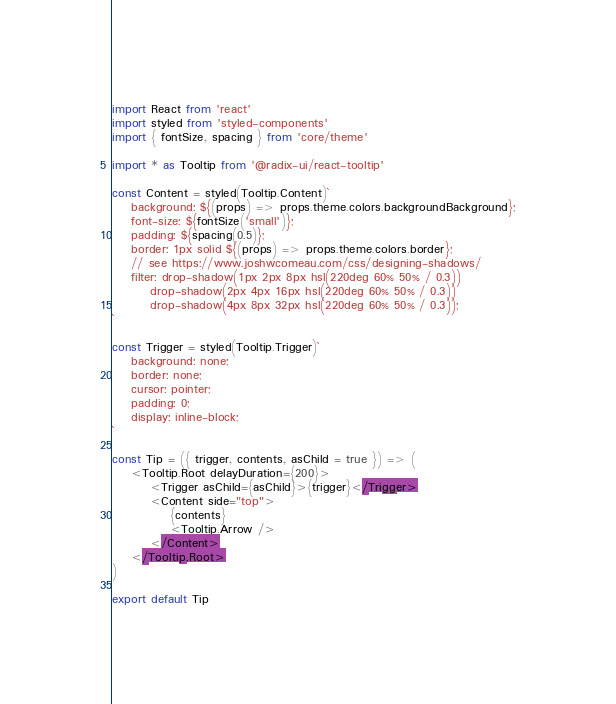Convert code to text. <code><loc_0><loc_0><loc_500><loc_500><_JavaScript_>import React from 'react'
import styled from 'styled-components'
import { fontSize, spacing } from 'core/theme'

import * as Tooltip from '@radix-ui/react-tooltip'

const Content = styled(Tooltip.Content)`
    background: ${(props) => props.theme.colors.backgroundBackground};
    font-size: ${fontSize('small')};
    padding: ${spacing(0.5)};
    border: 1px solid ${(props) => props.theme.colors.border};
    // see https://www.joshwcomeau.com/css/designing-shadows/
    filter: drop-shadow(1px 2px 8px hsl(220deg 60% 50% / 0.3))
        drop-shadow(2px 4px 16px hsl(220deg 60% 50% / 0.3))
        drop-shadow(4px 8px 32px hsl(220deg 60% 50% / 0.3));
`

const Trigger = styled(Tooltip.Trigger)`
    background: none;
    border: none;
    cursor: pointer;
    padding: 0;
    display: inline-block;
`

const Tip = ({ trigger, contents, asChild = true }) => (
    <Tooltip.Root delayDuration={200}>
        <Trigger asChild={asChild}>{trigger}</Trigger>
        <Content side="top">
            {contents}
            <Tooltip.Arrow />
        </Content>
    </Tooltip.Root>
)

export default Tip
</code> 